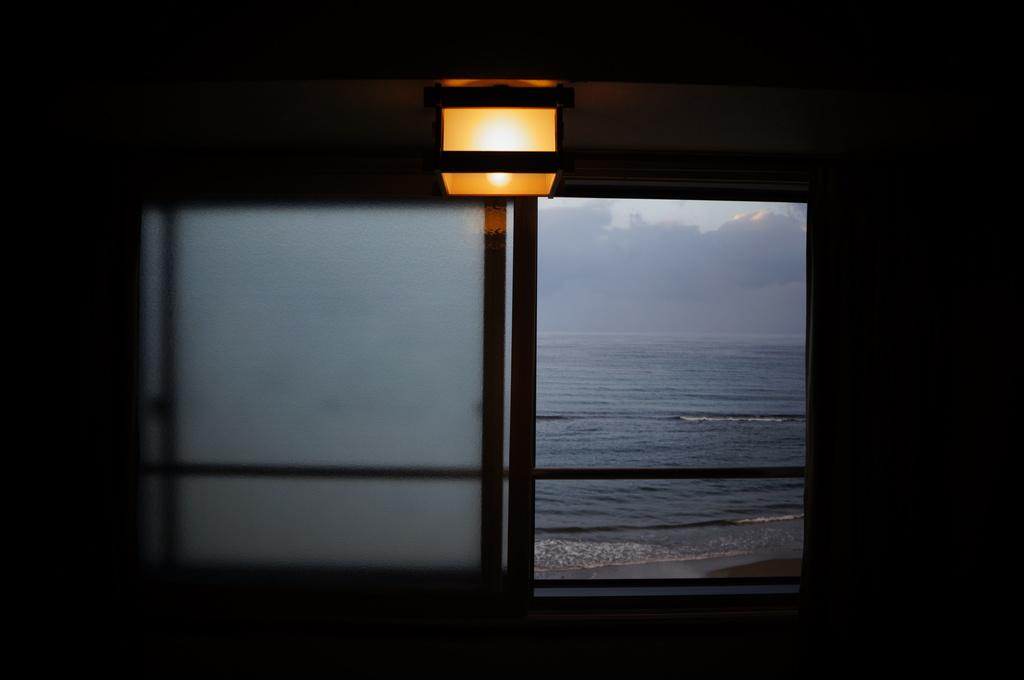What is located in the center of the image? There is a window in the center of the image. What can be seen through the window? Water and the sky are visible through the window. What is above the window in the image? There is a ceiling in the image. What is present on the ceiling? A light is present on the ceiling. How does the nerve system of the garden contribute to the image? There is no mention of a garden or nerve system in the image, so this question cannot be answered definitively. 